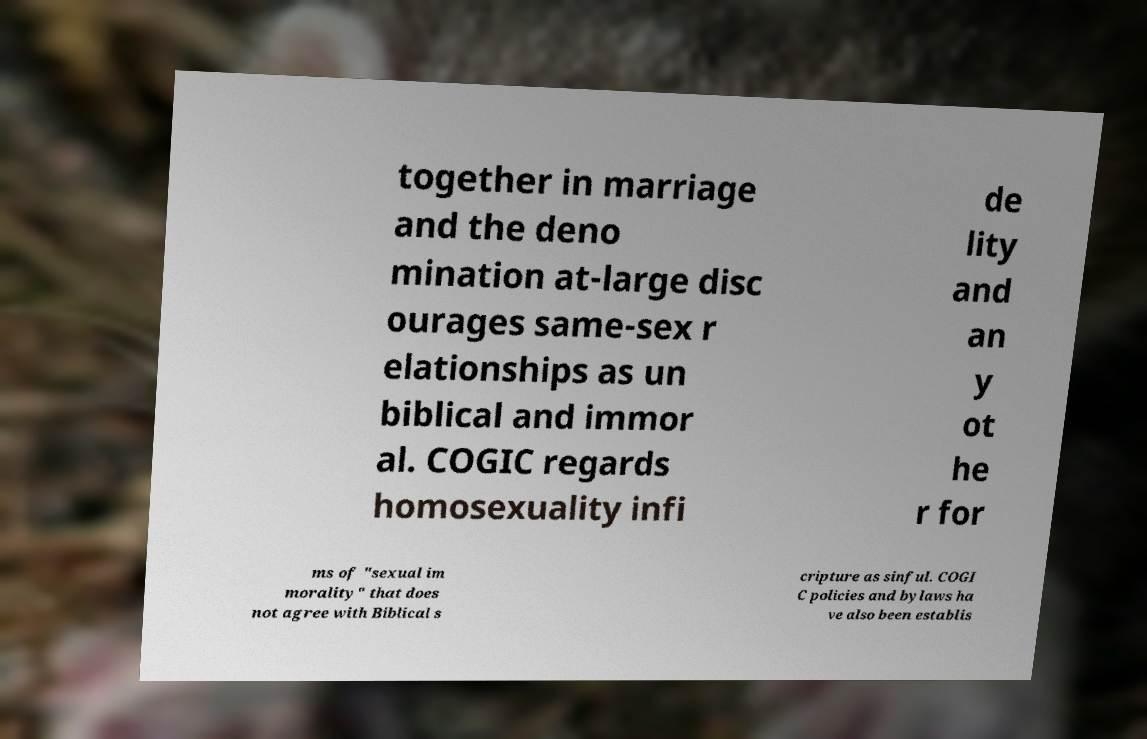Can you read and provide the text displayed in the image?This photo seems to have some interesting text. Can you extract and type it out for me? together in marriage and the deno mination at-large disc ourages same-sex r elationships as un biblical and immor al. COGIC regards homosexuality infi de lity and an y ot he r for ms of "sexual im morality" that does not agree with Biblical s cripture as sinful. COGI C policies and bylaws ha ve also been establis 